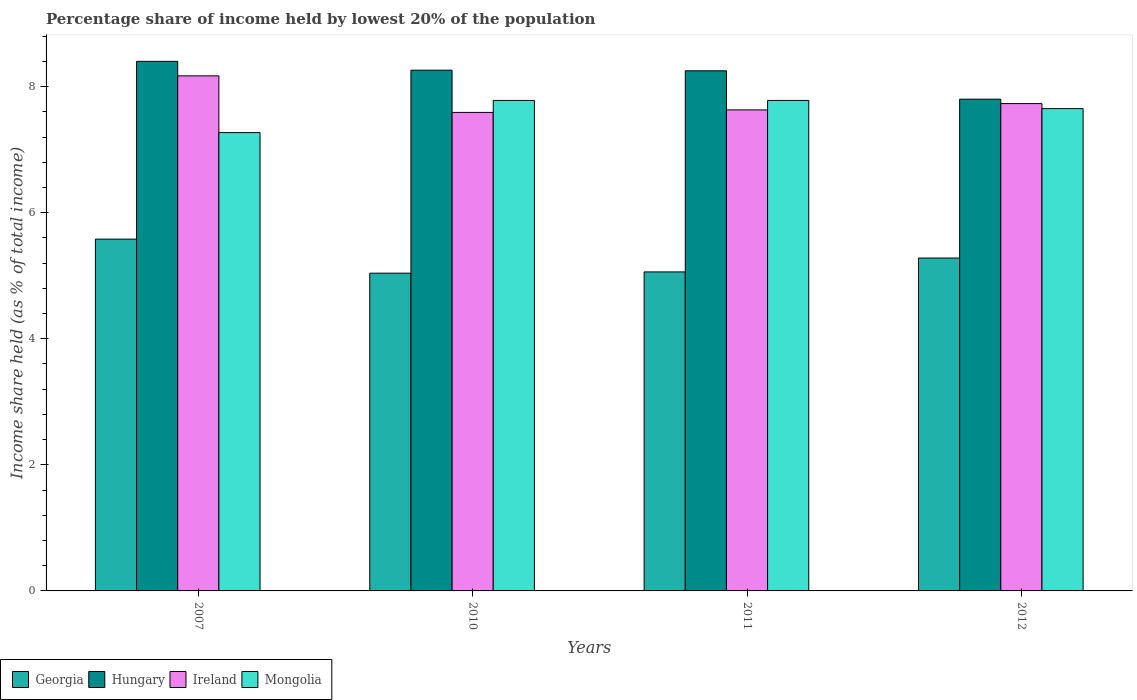How many groups of bars are there?
Offer a very short reply. 4. How many bars are there on the 1st tick from the left?
Your answer should be compact. 4. How many bars are there on the 1st tick from the right?
Provide a succinct answer. 4. What is the label of the 3rd group of bars from the left?
Offer a very short reply. 2011. In how many cases, is the number of bars for a given year not equal to the number of legend labels?
Provide a short and direct response. 0. Across all years, what is the maximum percentage share of income held by lowest 20% of the population in Georgia?
Offer a terse response. 5.58. Across all years, what is the minimum percentage share of income held by lowest 20% of the population in Georgia?
Offer a terse response. 5.04. In which year was the percentage share of income held by lowest 20% of the population in Ireland minimum?
Give a very brief answer. 2010. What is the total percentage share of income held by lowest 20% of the population in Mongolia in the graph?
Provide a succinct answer. 30.48. What is the difference between the percentage share of income held by lowest 20% of the population in Mongolia in 2007 and that in 2011?
Keep it short and to the point. -0.51. What is the difference between the percentage share of income held by lowest 20% of the population in Mongolia in 2007 and the percentage share of income held by lowest 20% of the population in Hungary in 2010?
Offer a terse response. -0.99. What is the average percentage share of income held by lowest 20% of the population in Mongolia per year?
Give a very brief answer. 7.62. In the year 2010, what is the difference between the percentage share of income held by lowest 20% of the population in Georgia and percentage share of income held by lowest 20% of the population in Ireland?
Your answer should be compact. -2.55. What is the ratio of the percentage share of income held by lowest 20% of the population in Hungary in 2011 to that in 2012?
Your response must be concise. 1.06. Is the difference between the percentage share of income held by lowest 20% of the population in Georgia in 2010 and 2011 greater than the difference between the percentage share of income held by lowest 20% of the population in Ireland in 2010 and 2011?
Your answer should be very brief. Yes. What is the difference between the highest and the second highest percentage share of income held by lowest 20% of the population in Mongolia?
Your answer should be compact. 0. What is the difference between the highest and the lowest percentage share of income held by lowest 20% of the population in Mongolia?
Your answer should be compact. 0.51. In how many years, is the percentage share of income held by lowest 20% of the population in Hungary greater than the average percentage share of income held by lowest 20% of the population in Hungary taken over all years?
Make the answer very short. 3. Is it the case that in every year, the sum of the percentage share of income held by lowest 20% of the population in Georgia and percentage share of income held by lowest 20% of the population in Ireland is greater than the sum of percentage share of income held by lowest 20% of the population in Mongolia and percentage share of income held by lowest 20% of the population in Hungary?
Your answer should be compact. No. What does the 3rd bar from the left in 2011 represents?
Ensure brevity in your answer.  Ireland. What does the 4th bar from the right in 2012 represents?
Keep it short and to the point. Georgia. Is it the case that in every year, the sum of the percentage share of income held by lowest 20% of the population in Georgia and percentage share of income held by lowest 20% of the population in Ireland is greater than the percentage share of income held by lowest 20% of the population in Hungary?
Make the answer very short. Yes. How many bars are there?
Offer a very short reply. 16. Are all the bars in the graph horizontal?
Provide a succinct answer. No. How many years are there in the graph?
Ensure brevity in your answer.  4. What is the difference between two consecutive major ticks on the Y-axis?
Keep it short and to the point. 2. Are the values on the major ticks of Y-axis written in scientific E-notation?
Provide a short and direct response. No. Where does the legend appear in the graph?
Provide a short and direct response. Bottom left. How are the legend labels stacked?
Your response must be concise. Horizontal. What is the title of the graph?
Offer a very short reply. Percentage share of income held by lowest 20% of the population. What is the label or title of the X-axis?
Ensure brevity in your answer.  Years. What is the label or title of the Y-axis?
Offer a terse response. Income share held (as % of total income). What is the Income share held (as % of total income) in Georgia in 2007?
Your answer should be compact. 5.58. What is the Income share held (as % of total income) of Hungary in 2007?
Offer a very short reply. 8.4. What is the Income share held (as % of total income) of Ireland in 2007?
Give a very brief answer. 8.17. What is the Income share held (as % of total income) of Mongolia in 2007?
Your answer should be very brief. 7.27. What is the Income share held (as % of total income) in Georgia in 2010?
Your response must be concise. 5.04. What is the Income share held (as % of total income) of Hungary in 2010?
Your answer should be compact. 8.26. What is the Income share held (as % of total income) of Ireland in 2010?
Your answer should be compact. 7.59. What is the Income share held (as % of total income) of Mongolia in 2010?
Give a very brief answer. 7.78. What is the Income share held (as % of total income) in Georgia in 2011?
Give a very brief answer. 5.06. What is the Income share held (as % of total income) of Hungary in 2011?
Offer a very short reply. 8.25. What is the Income share held (as % of total income) of Ireland in 2011?
Provide a succinct answer. 7.63. What is the Income share held (as % of total income) of Mongolia in 2011?
Provide a short and direct response. 7.78. What is the Income share held (as % of total income) in Georgia in 2012?
Keep it short and to the point. 5.28. What is the Income share held (as % of total income) of Ireland in 2012?
Provide a succinct answer. 7.73. What is the Income share held (as % of total income) in Mongolia in 2012?
Offer a very short reply. 7.65. Across all years, what is the maximum Income share held (as % of total income) in Georgia?
Make the answer very short. 5.58. Across all years, what is the maximum Income share held (as % of total income) of Ireland?
Ensure brevity in your answer.  8.17. Across all years, what is the maximum Income share held (as % of total income) in Mongolia?
Your answer should be very brief. 7.78. Across all years, what is the minimum Income share held (as % of total income) in Georgia?
Provide a succinct answer. 5.04. Across all years, what is the minimum Income share held (as % of total income) in Hungary?
Make the answer very short. 7.8. Across all years, what is the minimum Income share held (as % of total income) in Ireland?
Keep it short and to the point. 7.59. Across all years, what is the minimum Income share held (as % of total income) in Mongolia?
Make the answer very short. 7.27. What is the total Income share held (as % of total income) of Georgia in the graph?
Keep it short and to the point. 20.96. What is the total Income share held (as % of total income) of Hungary in the graph?
Offer a terse response. 32.71. What is the total Income share held (as % of total income) in Ireland in the graph?
Your answer should be very brief. 31.12. What is the total Income share held (as % of total income) in Mongolia in the graph?
Offer a very short reply. 30.48. What is the difference between the Income share held (as % of total income) in Georgia in 2007 and that in 2010?
Offer a very short reply. 0.54. What is the difference between the Income share held (as % of total income) of Hungary in 2007 and that in 2010?
Make the answer very short. 0.14. What is the difference between the Income share held (as % of total income) of Ireland in 2007 and that in 2010?
Provide a short and direct response. 0.58. What is the difference between the Income share held (as % of total income) of Mongolia in 2007 and that in 2010?
Your answer should be compact. -0.51. What is the difference between the Income share held (as % of total income) of Georgia in 2007 and that in 2011?
Make the answer very short. 0.52. What is the difference between the Income share held (as % of total income) of Hungary in 2007 and that in 2011?
Your answer should be very brief. 0.15. What is the difference between the Income share held (as % of total income) in Ireland in 2007 and that in 2011?
Ensure brevity in your answer.  0.54. What is the difference between the Income share held (as % of total income) of Mongolia in 2007 and that in 2011?
Ensure brevity in your answer.  -0.51. What is the difference between the Income share held (as % of total income) in Ireland in 2007 and that in 2012?
Give a very brief answer. 0.44. What is the difference between the Income share held (as % of total income) in Mongolia in 2007 and that in 2012?
Make the answer very short. -0.38. What is the difference between the Income share held (as % of total income) of Georgia in 2010 and that in 2011?
Offer a terse response. -0.02. What is the difference between the Income share held (as % of total income) of Hungary in 2010 and that in 2011?
Keep it short and to the point. 0.01. What is the difference between the Income share held (as % of total income) in Ireland in 2010 and that in 2011?
Offer a very short reply. -0.04. What is the difference between the Income share held (as % of total income) in Mongolia in 2010 and that in 2011?
Offer a terse response. 0. What is the difference between the Income share held (as % of total income) of Georgia in 2010 and that in 2012?
Your answer should be compact. -0.24. What is the difference between the Income share held (as % of total income) of Hungary in 2010 and that in 2012?
Your answer should be very brief. 0.46. What is the difference between the Income share held (as % of total income) of Ireland in 2010 and that in 2012?
Your answer should be compact. -0.14. What is the difference between the Income share held (as % of total income) in Mongolia in 2010 and that in 2012?
Ensure brevity in your answer.  0.13. What is the difference between the Income share held (as % of total income) in Georgia in 2011 and that in 2012?
Ensure brevity in your answer.  -0.22. What is the difference between the Income share held (as % of total income) in Hungary in 2011 and that in 2012?
Provide a short and direct response. 0.45. What is the difference between the Income share held (as % of total income) of Mongolia in 2011 and that in 2012?
Offer a terse response. 0.13. What is the difference between the Income share held (as % of total income) in Georgia in 2007 and the Income share held (as % of total income) in Hungary in 2010?
Ensure brevity in your answer.  -2.68. What is the difference between the Income share held (as % of total income) in Georgia in 2007 and the Income share held (as % of total income) in Ireland in 2010?
Provide a succinct answer. -2.01. What is the difference between the Income share held (as % of total income) in Hungary in 2007 and the Income share held (as % of total income) in Ireland in 2010?
Your answer should be compact. 0.81. What is the difference between the Income share held (as % of total income) of Hungary in 2007 and the Income share held (as % of total income) of Mongolia in 2010?
Your answer should be very brief. 0.62. What is the difference between the Income share held (as % of total income) in Ireland in 2007 and the Income share held (as % of total income) in Mongolia in 2010?
Provide a short and direct response. 0.39. What is the difference between the Income share held (as % of total income) in Georgia in 2007 and the Income share held (as % of total income) in Hungary in 2011?
Provide a succinct answer. -2.67. What is the difference between the Income share held (as % of total income) of Georgia in 2007 and the Income share held (as % of total income) of Ireland in 2011?
Your answer should be compact. -2.05. What is the difference between the Income share held (as % of total income) of Hungary in 2007 and the Income share held (as % of total income) of Ireland in 2011?
Your answer should be very brief. 0.77. What is the difference between the Income share held (as % of total income) in Hungary in 2007 and the Income share held (as % of total income) in Mongolia in 2011?
Offer a very short reply. 0.62. What is the difference between the Income share held (as % of total income) of Ireland in 2007 and the Income share held (as % of total income) of Mongolia in 2011?
Provide a succinct answer. 0.39. What is the difference between the Income share held (as % of total income) in Georgia in 2007 and the Income share held (as % of total income) in Hungary in 2012?
Make the answer very short. -2.22. What is the difference between the Income share held (as % of total income) of Georgia in 2007 and the Income share held (as % of total income) of Ireland in 2012?
Make the answer very short. -2.15. What is the difference between the Income share held (as % of total income) of Georgia in 2007 and the Income share held (as % of total income) of Mongolia in 2012?
Your response must be concise. -2.07. What is the difference between the Income share held (as % of total income) of Hungary in 2007 and the Income share held (as % of total income) of Ireland in 2012?
Make the answer very short. 0.67. What is the difference between the Income share held (as % of total income) of Ireland in 2007 and the Income share held (as % of total income) of Mongolia in 2012?
Give a very brief answer. 0.52. What is the difference between the Income share held (as % of total income) in Georgia in 2010 and the Income share held (as % of total income) in Hungary in 2011?
Your answer should be compact. -3.21. What is the difference between the Income share held (as % of total income) of Georgia in 2010 and the Income share held (as % of total income) of Ireland in 2011?
Provide a succinct answer. -2.59. What is the difference between the Income share held (as % of total income) of Georgia in 2010 and the Income share held (as % of total income) of Mongolia in 2011?
Make the answer very short. -2.74. What is the difference between the Income share held (as % of total income) of Hungary in 2010 and the Income share held (as % of total income) of Ireland in 2011?
Give a very brief answer. 0.63. What is the difference between the Income share held (as % of total income) of Hungary in 2010 and the Income share held (as % of total income) of Mongolia in 2011?
Keep it short and to the point. 0.48. What is the difference between the Income share held (as % of total income) of Ireland in 2010 and the Income share held (as % of total income) of Mongolia in 2011?
Ensure brevity in your answer.  -0.19. What is the difference between the Income share held (as % of total income) in Georgia in 2010 and the Income share held (as % of total income) in Hungary in 2012?
Your response must be concise. -2.76. What is the difference between the Income share held (as % of total income) in Georgia in 2010 and the Income share held (as % of total income) in Ireland in 2012?
Keep it short and to the point. -2.69. What is the difference between the Income share held (as % of total income) in Georgia in 2010 and the Income share held (as % of total income) in Mongolia in 2012?
Make the answer very short. -2.61. What is the difference between the Income share held (as % of total income) of Hungary in 2010 and the Income share held (as % of total income) of Ireland in 2012?
Make the answer very short. 0.53. What is the difference between the Income share held (as % of total income) in Hungary in 2010 and the Income share held (as % of total income) in Mongolia in 2012?
Keep it short and to the point. 0.61. What is the difference between the Income share held (as % of total income) in Ireland in 2010 and the Income share held (as % of total income) in Mongolia in 2012?
Give a very brief answer. -0.06. What is the difference between the Income share held (as % of total income) in Georgia in 2011 and the Income share held (as % of total income) in Hungary in 2012?
Your response must be concise. -2.74. What is the difference between the Income share held (as % of total income) of Georgia in 2011 and the Income share held (as % of total income) of Ireland in 2012?
Provide a succinct answer. -2.67. What is the difference between the Income share held (as % of total income) in Georgia in 2011 and the Income share held (as % of total income) in Mongolia in 2012?
Your answer should be very brief. -2.59. What is the difference between the Income share held (as % of total income) of Hungary in 2011 and the Income share held (as % of total income) of Ireland in 2012?
Your answer should be very brief. 0.52. What is the difference between the Income share held (as % of total income) in Ireland in 2011 and the Income share held (as % of total income) in Mongolia in 2012?
Your response must be concise. -0.02. What is the average Income share held (as % of total income) in Georgia per year?
Keep it short and to the point. 5.24. What is the average Income share held (as % of total income) in Hungary per year?
Your answer should be compact. 8.18. What is the average Income share held (as % of total income) of Ireland per year?
Provide a succinct answer. 7.78. What is the average Income share held (as % of total income) of Mongolia per year?
Your answer should be compact. 7.62. In the year 2007, what is the difference between the Income share held (as % of total income) in Georgia and Income share held (as % of total income) in Hungary?
Keep it short and to the point. -2.82. In the year 2007, what is the difference between the Income share held (as % of total income) in Georgia and Income share held (as % of total income) in Ireland?
Ensure brevity in your answer.  -2.59. In the year 2007, what is the difference between the Income share held (as % of total income) of Georgia and Income share held (as % of total income) of Mongolia?
Keep it short and to the point. -1.69. In the year 2007, what is the difference between the Income share held (as % of total income) in Hungary and Income share held (as % of total income) in Ireland?
Make the answer very short. 0.23. In the year 2007, what is the difference between the Income share held (as % of total income) of Hungary and Income share held (as % of total income) of Mongolia?
Make the answer very short. 1.13. In the year 2010, what is the difference between the Income share held (as % of total income) in Georgia and Income share held (as % of total income) in Hungary?
Keep it short and to the point. -3.22. In the year 2010, what is the difference between the Income share held (as % of total income) of Georgia and Income share held (as % of total income) of Ireland?
Your answer should be compact. -2.55. In the year 2010, what is the difference between the Income share held (as % of total income) in Georgia and Income share held (as % of total income) in Mongolia?
Keep it short and to the point. -2.74. In the year 2010, what is the difference between the Income share held (as % of total income) in Hungary and Income share held (as % of total income) in Ireland?
Offer a very short reply. 0.67. In the year 2010, what is the difference between the Income share held (as % of total income) of Hungary and Income share held (as % of total income) of Mongolia?
Give a very brief answer. 0.48. In the year 2010, what is the difference between the Income share held (as % of total income) of Ireland and Income share held (as % of total income) of Mongolia?
Your response must be concise. -0.19. In the year 2011, what is the difference between the Income share held (as % of total income) of Georgia and Income share held (as % of total income) of Hungary?
Provide a short and direct response. -3.19. In the year 2011, what is the difference between the Income share held (as % of total income) in Georgia and Income share held (as % of total income) in Ireland?
Make the answer very short. -2.57. In the year 2011, what is the difference between the Income share held (as % of total income) in Georgia and Income share held (as % of total income) in Mongolia?
Keep it short and to the point. -2.72. In the year 2011, what is the difference between the Income share held (as % of total income) of Hungary and Income share held (as % of total income) of Ireland?
Your answer should be compact. 0.62. In the year 2011, what is the difference between the Income share held (as % of total income) of Hungary and Income share held (as % of total income) of Mongolia?
Provide a short and direct response. 0.47. In the year 2011, what is the difference between the Income share held (as % of total income) in Ireland and Income share held (as % of total income) in Mongolia?
Make the answer very short. -0.15. In the year 2012, what is the difference between the Income share held (as % of total income) of Georgia and Income share held (as % of total income) of Hungary?
Ensure brevity in your answer.  -2.52. In the year 2012, what is the difference between the Income share held (as % of total income) in Georgia and Income share held (as % of total income) in Ireland?
Make the answer very short. -2.45. In the year 2012, what is the difference between the Income share held (as % of total income) in Georgia and Income share held (as % of total income) in Mongolia?
Make the answer very short. -2.37. In the year 2012, what is the difference between the Income share held (as % of total income) of Hungary and Income share held (as % of total income) of Ireland?
Your answer should be very brief. 0.07. What is the ratio of the Income share held (as % of total income) of Georgia in 2007 to that in 2010?
Ensure brevity in your answer.  1.11. What is the ratio of the Income share held (as % of total income) in Hungary in 2007 to that in 2010?
Provide a succinct answer. 1.02. What is the ratio of the Income share held (as % of total income) in Ireland in 2007 to that in 2010?
Provide a succinct answer. 1.08. What is the ratio of the Income share held (as % of total income) in Mongolia in 2007 to that in 2010?
Keep it short and to the point. 0.93. What is the ratio of the Income share held (as % of total income) of Georgia in 2007 to that in 2011?
Provide a succinct answer. 1.1. What is the ratio of the Income share held (as % of total income) in Hungary in 2007 to that in 2011?
Provide a succinct answer. 1.02. What is the ratio of the Income share held (as % of total income) in Ireland in 2007 to that in 2011?
Give a very brief answer. 1.07. What is the ratio of the Income share held (as % of total income) in Mongolia in 2007 to that in 2011?
Provide a short and direct response. 0.93. What is the ratio of the Income share held (as % of total income) of Georgia in 2007 to that in 2012?
Your response must be concise. 1.06. What is the ratio of the Income share held (as % of total income) in Hungary in 2007 to that in 2012?
Make the answer very short. 1.08. What is the ratio of the Income share held (as % of total income) in Ireland in 2007 to that in 2012?
Offer a very short reply. 1.06. What is the ratio of the Income share held (as % of total income) in Mongolia in 2007 to that in 2012?
Your answer should be compact. 0.95. What is the ratio of the Income share held (as % of total income) of Georgia in 2010 to that in 2011?
Ensure brevity in your answer.  1. What is the ratio of the Income share held (as % of total income) in Ireland in 2010 to that in 2011?
Your response must be concise. 0.99. What is the ratio of the Income share held (as % of total income) in Georgia in 2010 to that in 2012?
Provide a succinct answer. 0.95. What is the ratio of the Income share held (as % of total income) in Hungary in 2010 to that in 2012?
Make the answer very short. 1.06. What is the ratio of the Income share held (as % of total income) in Ireland in 2010 to that in 2012?
Offer a very short reply. 0.98. What is the ratio of the Income share held (as % of total income) of Mongolia in 2010 to that in 2012?
Offer a terse response. 1.02. What is the ratio of the Income share held (as % of total income) in Georgia in 2011 to that in 2012?
Your answer should be very brief. 0.96. What is the ratio of the Income share held (as % of total income) in Hungary in 2011 to that in 2012?
Your answer should be compact. 1.06. What is the ratio of the Income share held (as % of total income) in Ireland in 2011 to that in 2012?
Offer a terse response. 0.99. What is the difference between the highest and the second highest Income share held (as % of total income) of Georgia?
Give a very brief answer. 0.3. What is the difference between the highest and the second highest Income share held (as % of total income) in Hungary?
Give a very brief answer. 0.14. What is the difference between the highest and the second highest Income share held (as % of total income) in Ireland?
Provide a succinct answer. 0.44. What is the difference between the highest and the lowest Income share held (as % of total income) in Georgia?
Keep it short and to the point. 0.54. What is the difference between the highest and the lowest Income share held (as % of total income) of Ireland?
Offer a very short reply. 0.58. What is the difference between the highest and the lowest Income share held (as % of total income) of Mongolia?
Ensure brevity in your answer.  0.51. 